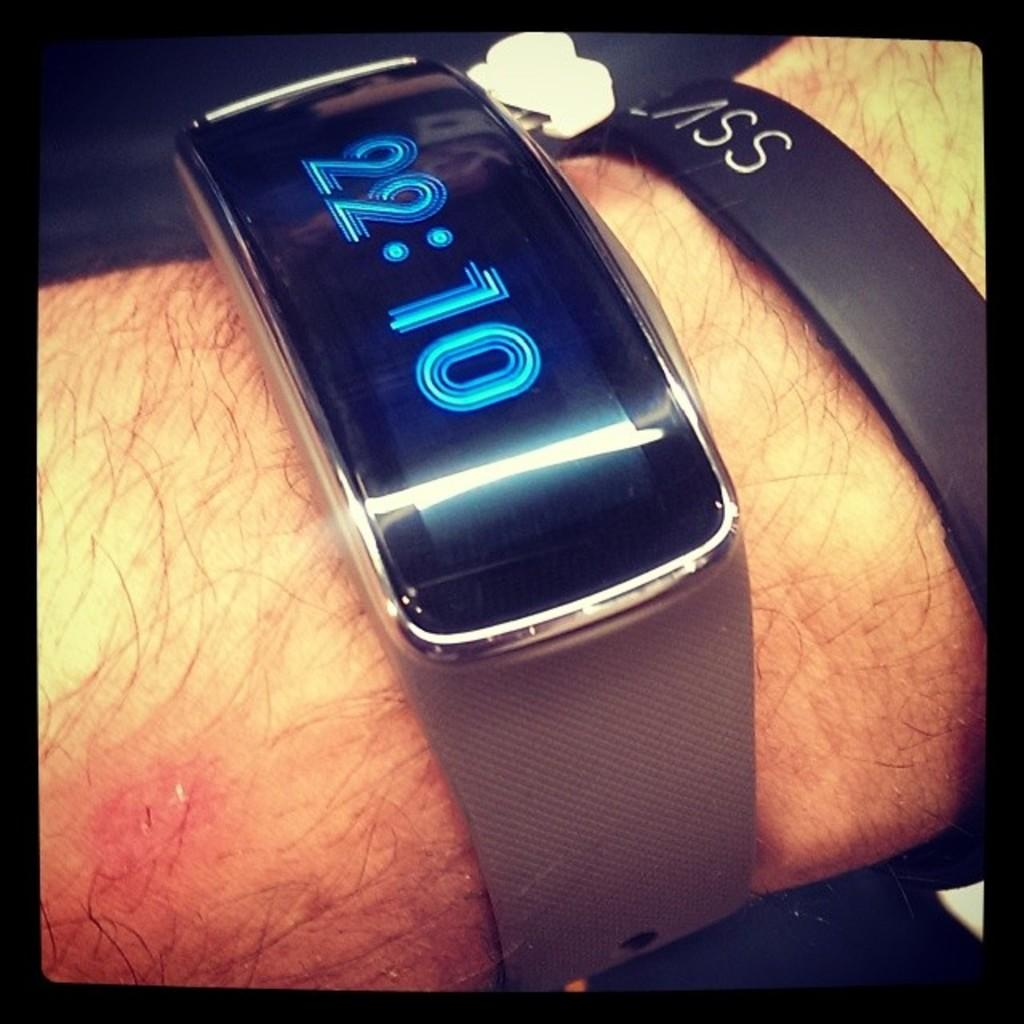Provide a one-sentence caption for the provided image. Large rose gold metallic smart watch with wrist-sized rectangular display, black screen with light blue numbering showing time to be 22:10. 